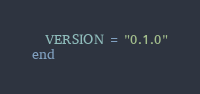<code> <loc_0><loc_0><loc_500><loc_500><_Ruby_>  VERSION = "0.1.0"
end
</code> 